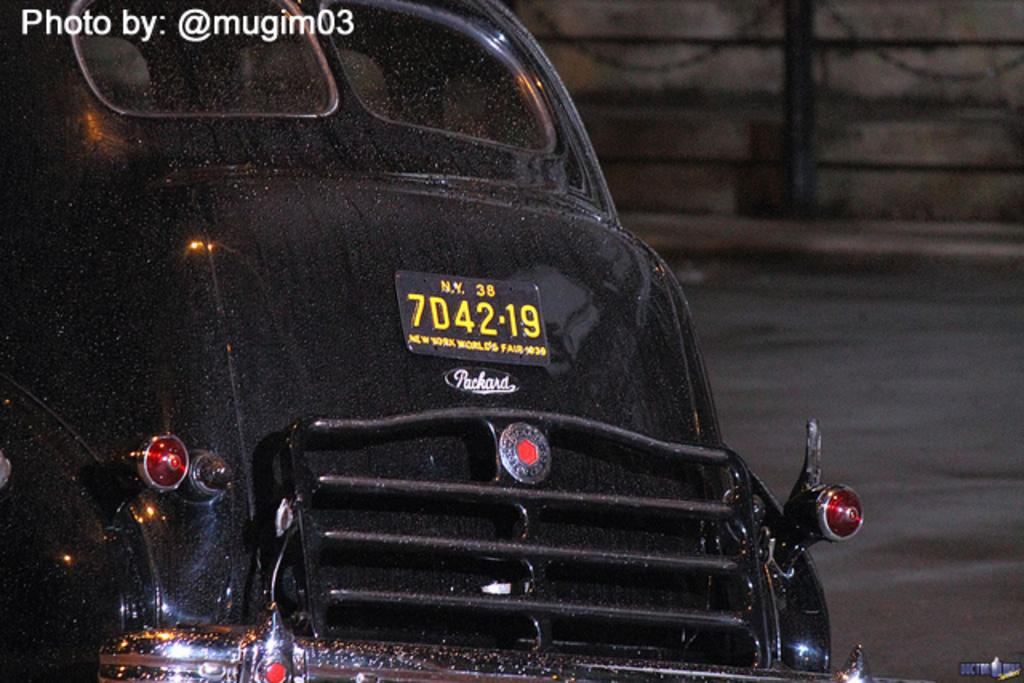What is the main subject of the image? There is a vehicle in the image. What is the setting of the image? There is a road in the image. What type of barriers are present in the image? Chain barriers are present in the image. Can you describe any imperfections or marks on the image? There are watermarks on the image. What attempt is being made by the society in the image? There is no indication of any attempt or society in the image; it primarily features a vehicle, a road, and chain barriers. How can the watermarks be washed off the image? The watermarks are not physical marks on the image, but rather digital imperfections, so they cannot be washed off. 